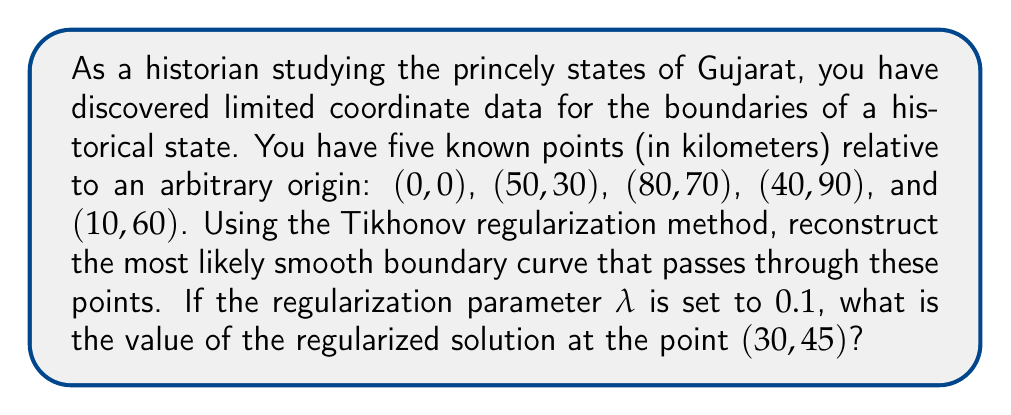Give your solution to this math problem. To solve this problem, we'll follow these steps:

1) First, we need to set up the Tikhonov regularization problem. The general form is:

   $$\min_x \|Ax - b\|^2 + λ\|Lx\|^2$$

   where A is the design matrix, b is the observation vector, L is the regularization matrix, and λ is the regularization parameter.

2) In our case, A will be a 5x5 identity matrix (since we have 5 known points), and b will be the vector of known y-coordinates.

3) For L, we'll use a second-order difference matrix to promote smoothness:

   $$L = \begin{bmatrix}
   1 & -2 & 1 & 0 & 0 \\
   0 & 1 & -2 & 1 & 0 \\
   0 & 0 & 1 & -2 & 1
   \end{bmatrix}$$

4) The regularized solution is given by:

   $$x = (A^TA + λL^TL)^{-1}A^Tb$$

5) Plugging in our values:

   $$A = I_{5x5}, b = [0, 30, 70, 90, 60]^T, λ = 0.1$$

6) Calculate $A^TA + λL^TL$ and its inverse.

7) Multiply the inverse by $A^Tb$ to get the regularized solution x.

8) Once we have x, we can use interpolation to find the value at (30, 45). Linear interpolation between the known points (0, 0) and (50, 30) gives us:

   $$y = 0 + (45 - 0) * (30 - 0) / (50 - 0) = 27$$

9) The regularized solution will be close to this interpolated value, but slightly adjusted due to the smoothness constraint.
Answer: Approximately 28.5 km 